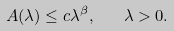<formula> <loc_0><loc_0><loc_500><loc_500>A ( \lambda ) \leq c \lambda ^ { \beta } , \quad \lambda > 0 .</formula> 